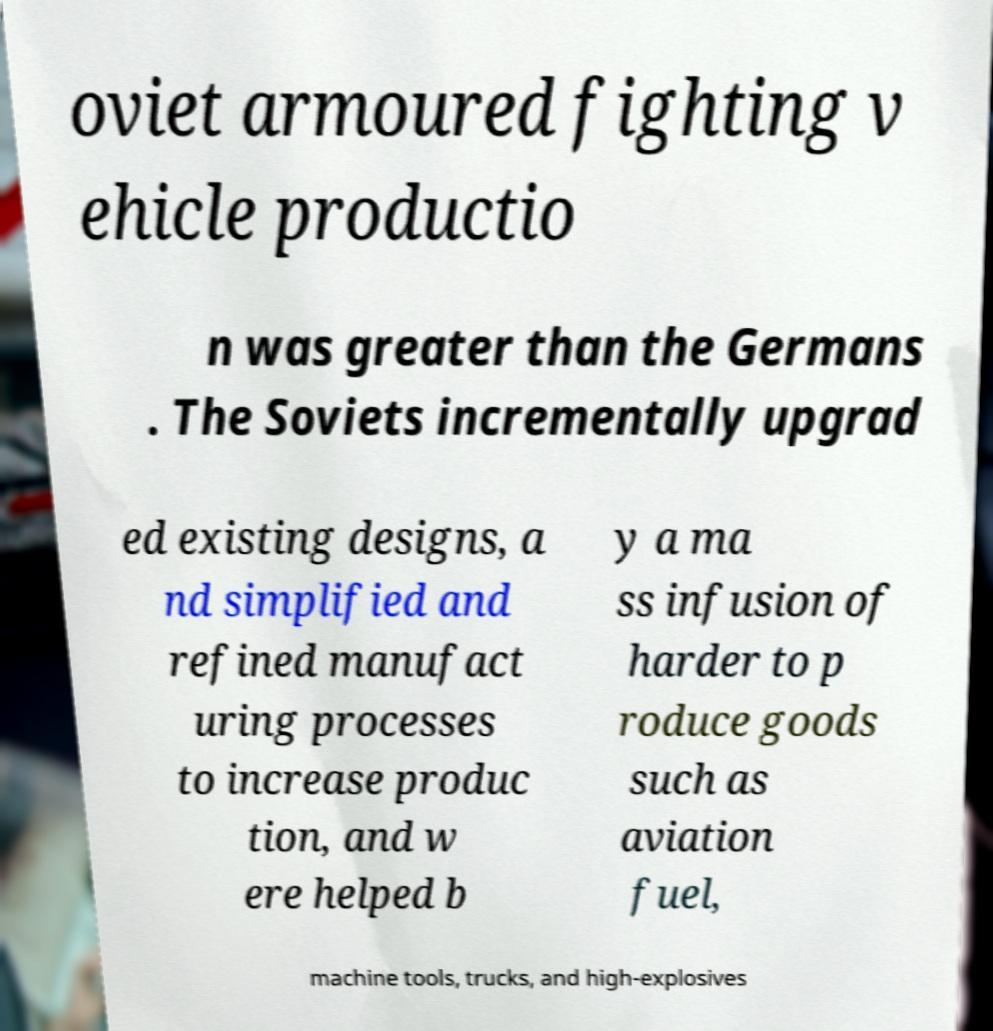For documentation purposes, I need the text within this image transcribed. Could you provide that? oviet armoured fighting v ehicle productio n was greater than the Germans . The Soviets incrementally upgrad ed existing designs, a nd simplified and refined manufact uring processes to increase produc tion, and w ere helped b y a ma ss infusion of harder to p roduce goods such as aviation fuel, machine tools, trucks, and high-explosives 